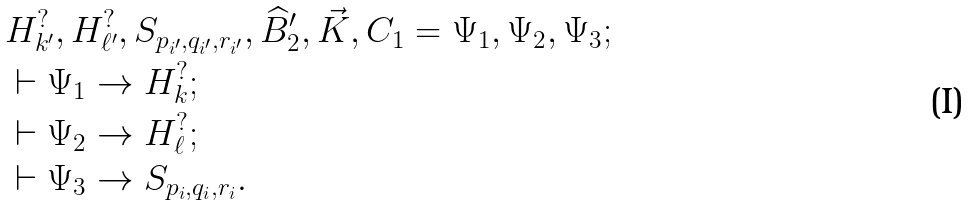Convert formula to latex. <formula><loc_0><loc_0><loc_500><loc_500>& H _ { k ^ { \prime } } ^ { ? } , H _ { \ell ^ { \prime } } ^ { ? } , S _ { p _ { i ^ { \prime } } , q _ { i ^ { \prime } } , r _ { i ^ { \prime } } } , \widehat { B } ^ { \prime } _ { 2 } , \vec { K } , C _ { 1 } = \Psi _ { 1 } , \Psi _ { 2 } , \Psi _ { 3 } ; \\ & \vdash \Psi _ { 1 } \to H _ { k } ^ { ? } ; \\ & \vdash \Psi _ { 2 } \to H _ { \ell } ^ { ? } ; \\ & \vdash \Psi _ { 3 } \to S _ { p _ { i } , q _ { i } , r _ { i } } .</formula> 